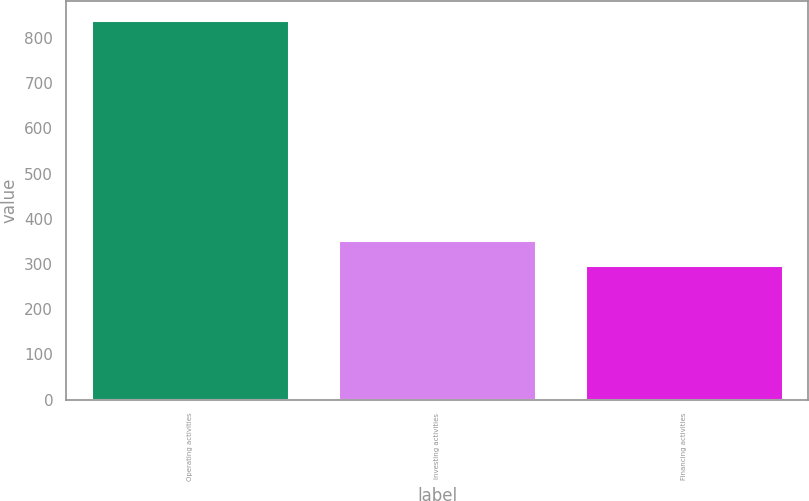<chart> <loc_0><loc_0><loc_500><loc_500><bar_chart><fcel>Operating activities<fcel>Investing activities<fcel>Financing activities<nl><fcel>840.4<fcel>352.33<fcel>298.1<nl></chart> 